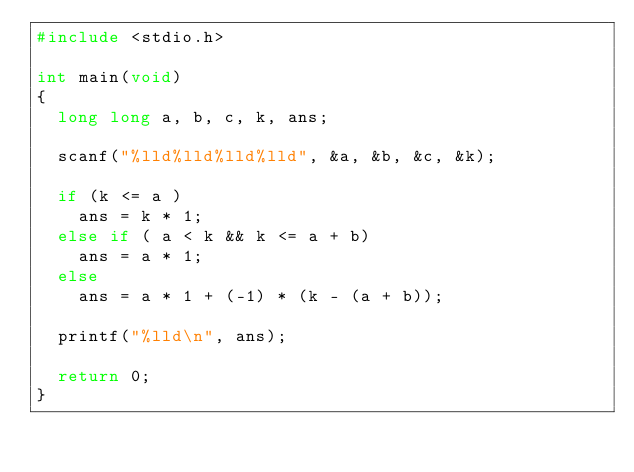<code> <loc_0><loc_0><loc_500><loc_500><_C_>#include <stdio.h>

int main(void)
{
  long long a, b, c, k, ans;

  scanf("%lld%lld%lld%lld", &a, &b, &c, &k);

  if (k <= a )
    ans = k * 1;
  else if ( a < k && k <= a + b)
    ans = a * 1;
  else 
    ans = a * 1 + (-1) * (k - (a + b));

  printf("%lld\n", ans);

  return 0;
}
</code> 